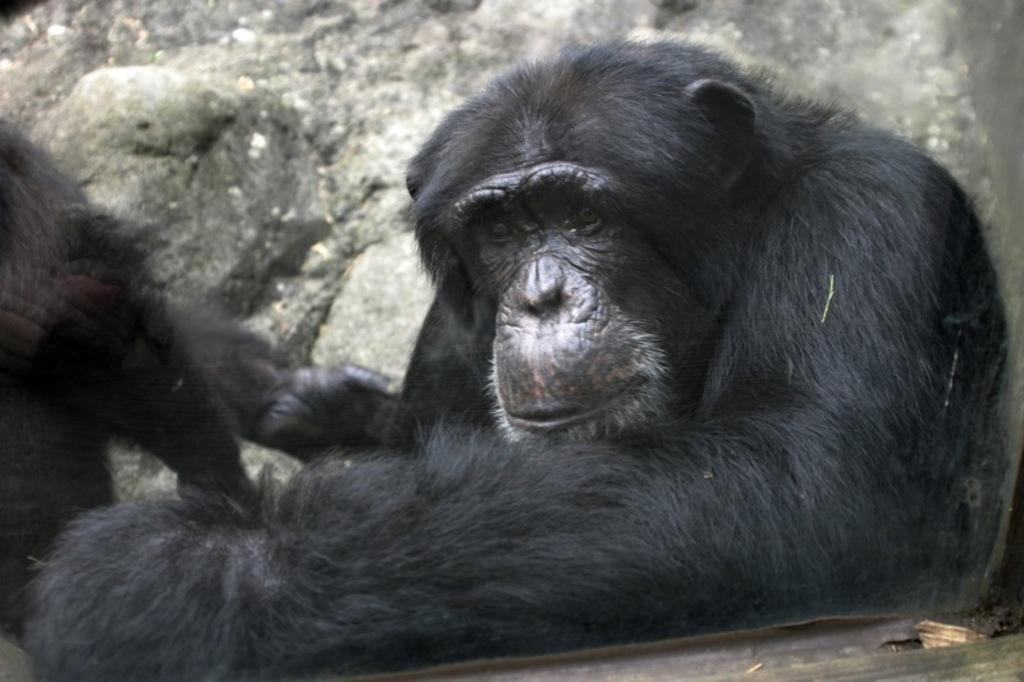How many chimpanzees are present in the image? There are two chimpanzees in the image. What can be seen in the background of the image? Rocks are visible in the background of the image. What type of rings can be seen on the chimpanzees' fingers in the image? There are no rings visible on the chimpanzees' fingers in the image, as chimpanzees do not wear rings. 